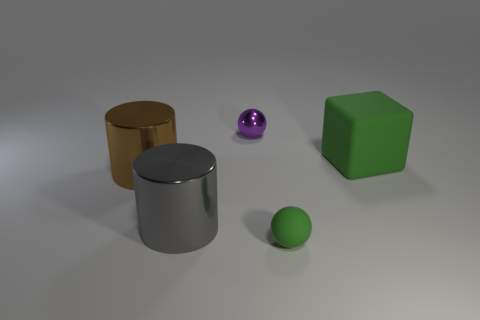Are any big brown cylinders visible?
Offer a terse response. Yes. Does the tiny sphere in front of the tiny purple shiny sphere have the same material as the gray object?
Offer a very short reply. No. Is there a gray object of the same shape as the purple thing?
Offer a terse response. No. Are there an equal number of things right of the big gray cylinder and big brown cylinders?
Provide a succinct answer. No. The sphere that is behind the large object that is on the right side of the purple metallic object is made of what material?
Make the answer very short. Metal. What is the shape of the gray object?
Offer a terse response. Cylinder. Are there an equal number of large green things on the left side of the brown object and tiny green rubber things on the right side of the small green rubber ball?
Offer a very short reply. Yes. Do the big cube behind the gray thing and the small metal ball on the left side of the green rubber ball have the same color?
Make the answer very short. No. Are there more gray things that are behind the large gray object than cubes?
Provide a succinct answer. No. What shape is the big brown object that is the same material as the small purple ball?
Keep it short and to the point. Cylinder. 